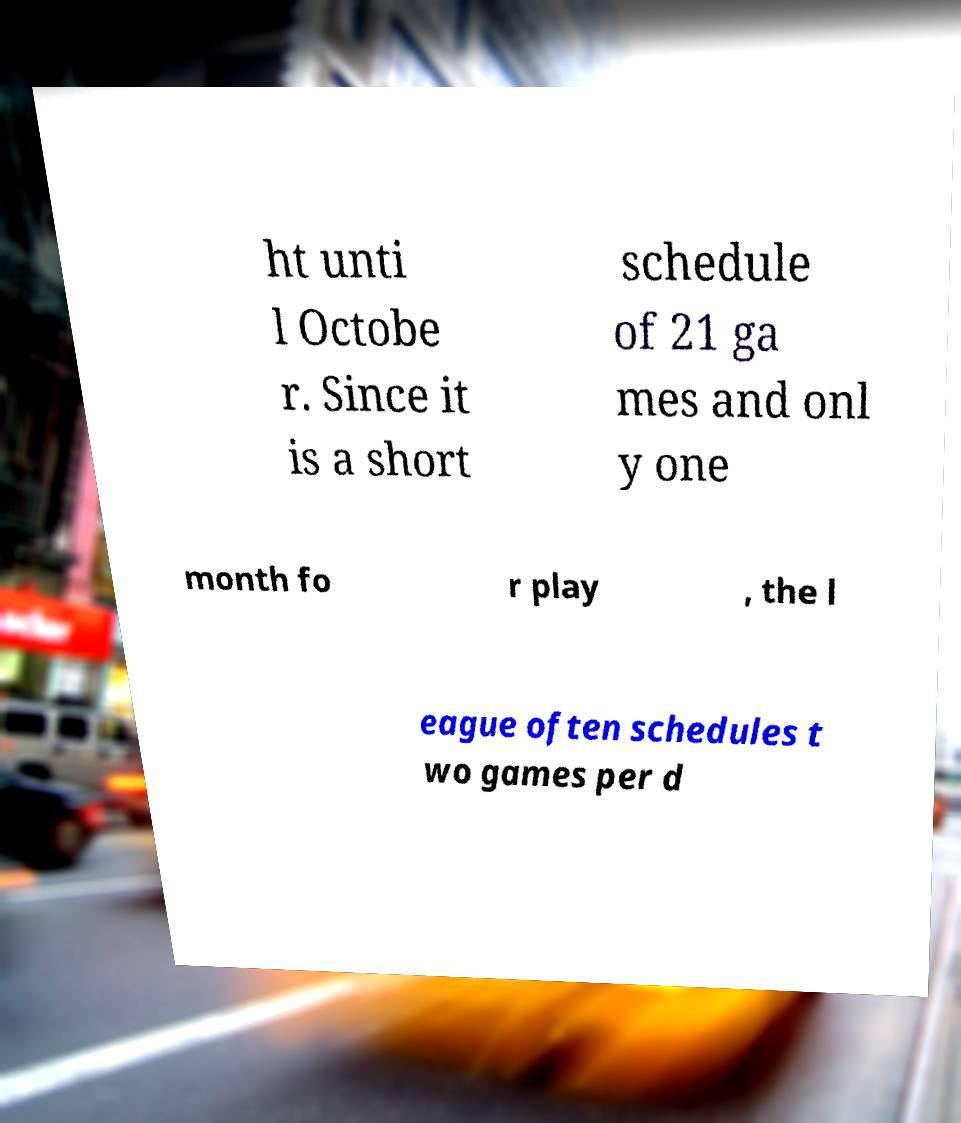I need the written content from this picture converted into text. Can you do that? ht unti l Octobe r. Since it is a short schedule of 21 ga mes and onl y one month fo r play , the l eague often schedules t wo games per d 